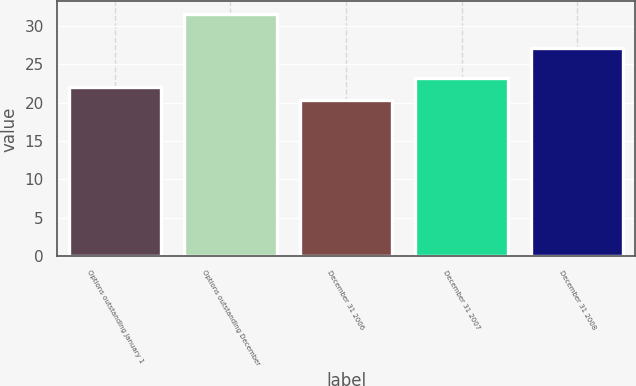Convert chart. <chart><loc_0><loc_0><loc_500><loc_500><bar_chart><fcel>Options outstanding January 1<fcel>Options outstanding December<fcel>December 31 2006<fcel>December 31 2007<fcel>December 31 2008<nl><fcel>22.06<fcel>31.58<fcel>20.37<fcel>23.18<fcel>27.05<nl></chart> 